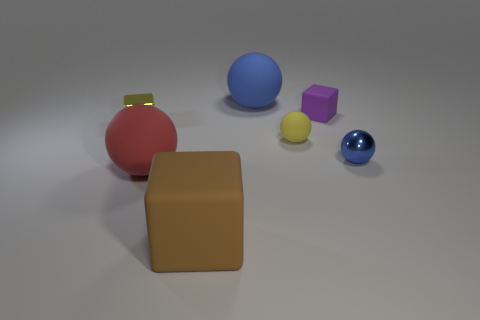Do the tiny metal sphere and the small matte sphere have the same color?
Make the answer very short. No. The matte ball that is the same color as the metal cube is what size?
Offer a very short reply. Small. There is a big block; does it have the same color as the rubber ball left of the blue rubber sphere?
Provide a short and direct response. No. There is a large thing that is the same color as the tiny metal sphere; what shape is it?
Ensure brevity in your answer.  Sphere. There is a block in front of the metal object in front of the yellow thing on the left side of the big blue matte thing; what is its material?
Provide a short and direct response. Rubber. There is a tiny thing that is behind the yellow shiny object; does it have the same shape as the brown object?
Offer a very short reply. Yes. There is a small yellow object that is on the left side of the tiny yellow matte thing; what material is it?
Keep it short and to the point. Metal. What number of rubber things are large things or small purple objects?
Offer a terse response. 4. Are there any metal cubes of the same size as the purple matte block?
Offer a very short reply. Yes. Is the number of big blue matte objects left of the small purple rubber thing greater than the number of small blue balls?
Give a very brief answer. No. 